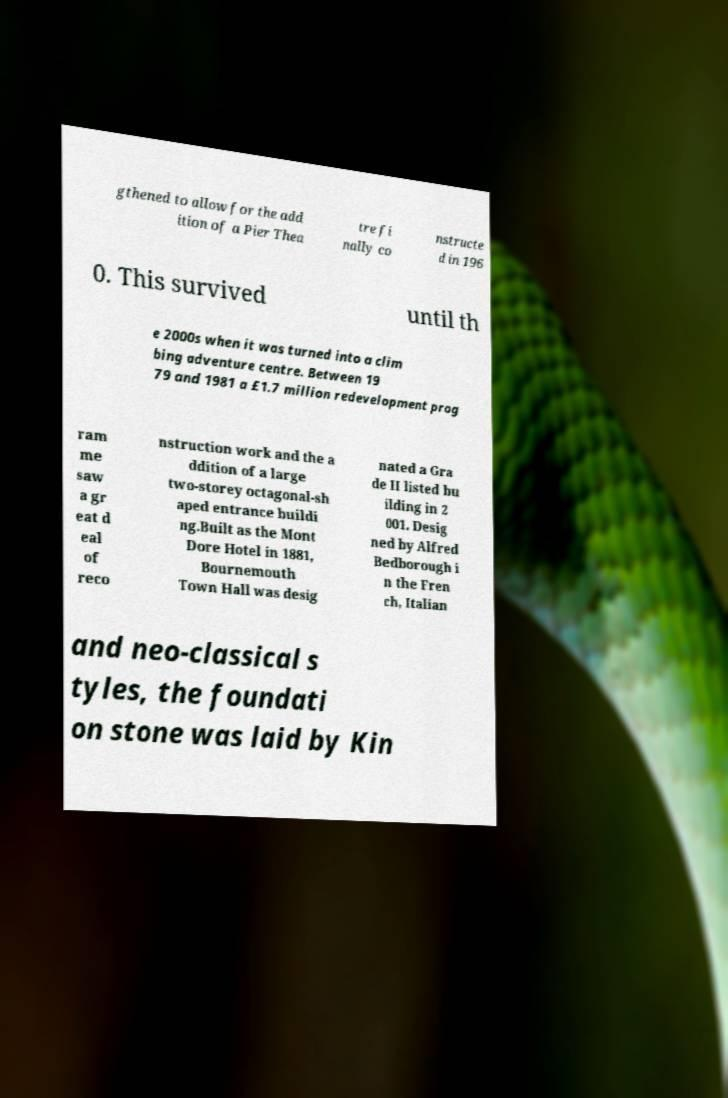For documentation purposes, I need the text within this image transcribed. Could you provide that? gthened to allow for the add ition of a Pier Thea tre fi nally co nstructe d in 196 0. This survived until th e 2000s when it was turned into a clim bing adventure centre. Between 19 79 and 1981 a £1.7 million redevelopment prog ram me saw a gr eat d eal of reco nstruction work and the a ddition of a large two-storey octagonal-sh aped entrance buildi ng.Built as the Mont Dore Hotel in 1881, Bournemouth Town Hall was desig nated a Gra de II listed bu ilding in 2 001. Desig ned by Alfred Bedborough i n the Fren ch, Italian and neo-classical s tyles, the foundati on stone was laid by Kin 